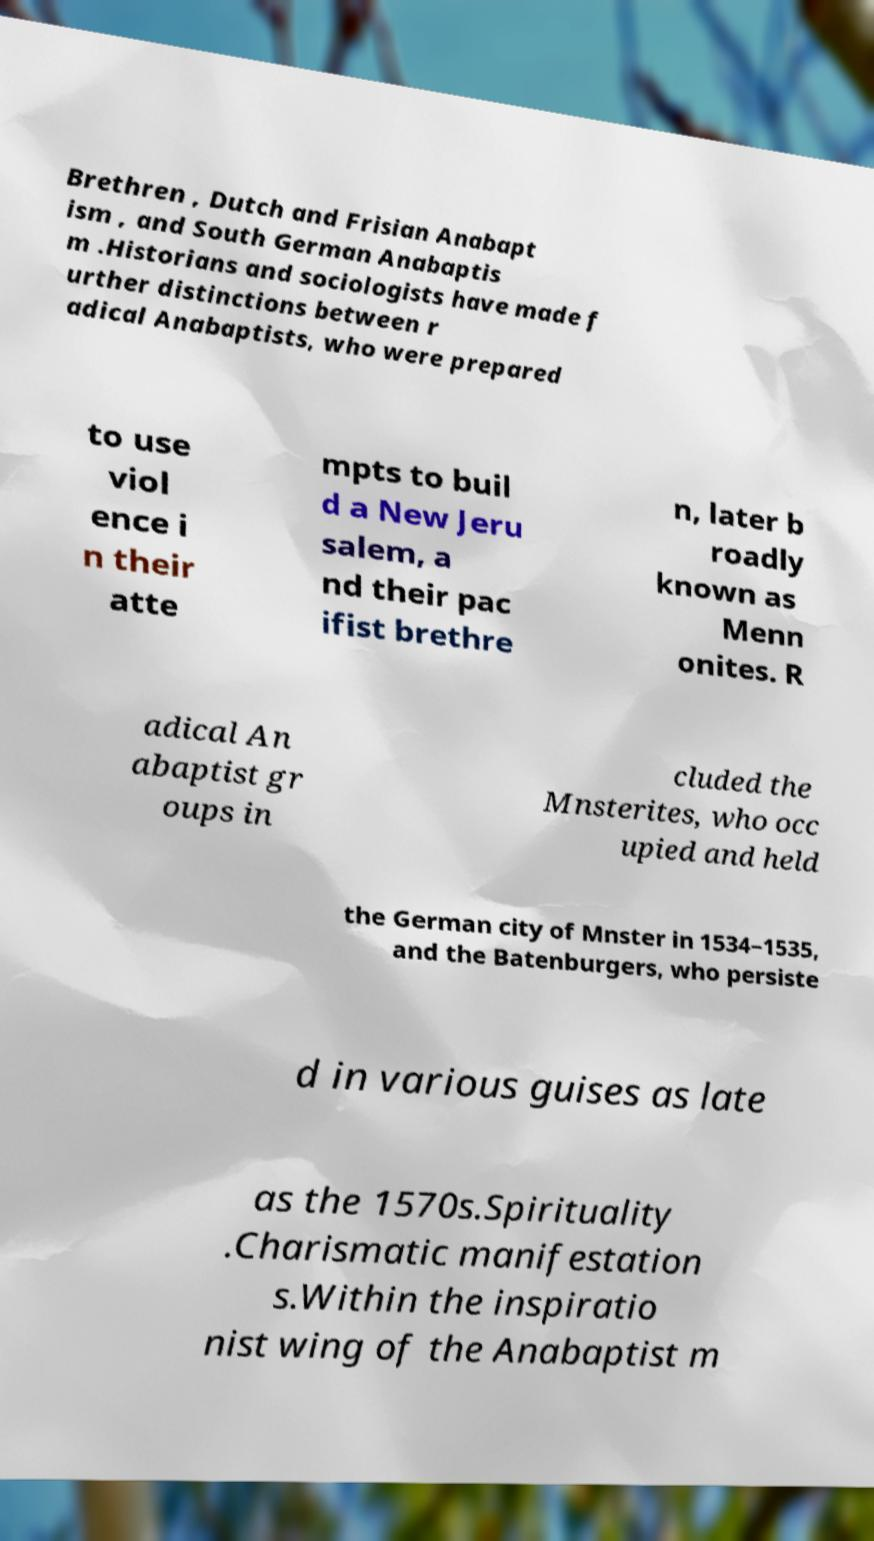Please identify and transcribe the text found in this image. Brethren , Dutch and Frisian Anabapt ism , and South German Anabaptis m .Historians and sociologists have made f urther distinctions between r adical Anabaptists, who were prepared to use viol ence i n their atte mpts to buil d a New Jeru salem, a nd their pac ifist brethre n, later b roadly known as Menn onites. R adical An abaptist gr oups in cluded the Mnsterites, who occ upied and held the German city of Mnster in 1534–1535, and the Batenburgers, who persiste d in various guises as late as the 1570s.Spirituality .Charismatic manifestation s.Within the inspiratio nist wing of the Anabaptist m 